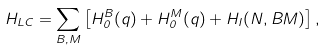<formula> <loc_0><loc_0><loc_500><loc_500>H _ { L C } = \sum _ { B , M } \left [ H _ { 0 } ^ { B } ( q ) + H _ { 0 } ^ { M } ( q ) + H _ { I } ( N , B M ) \right ] ,</formula> 